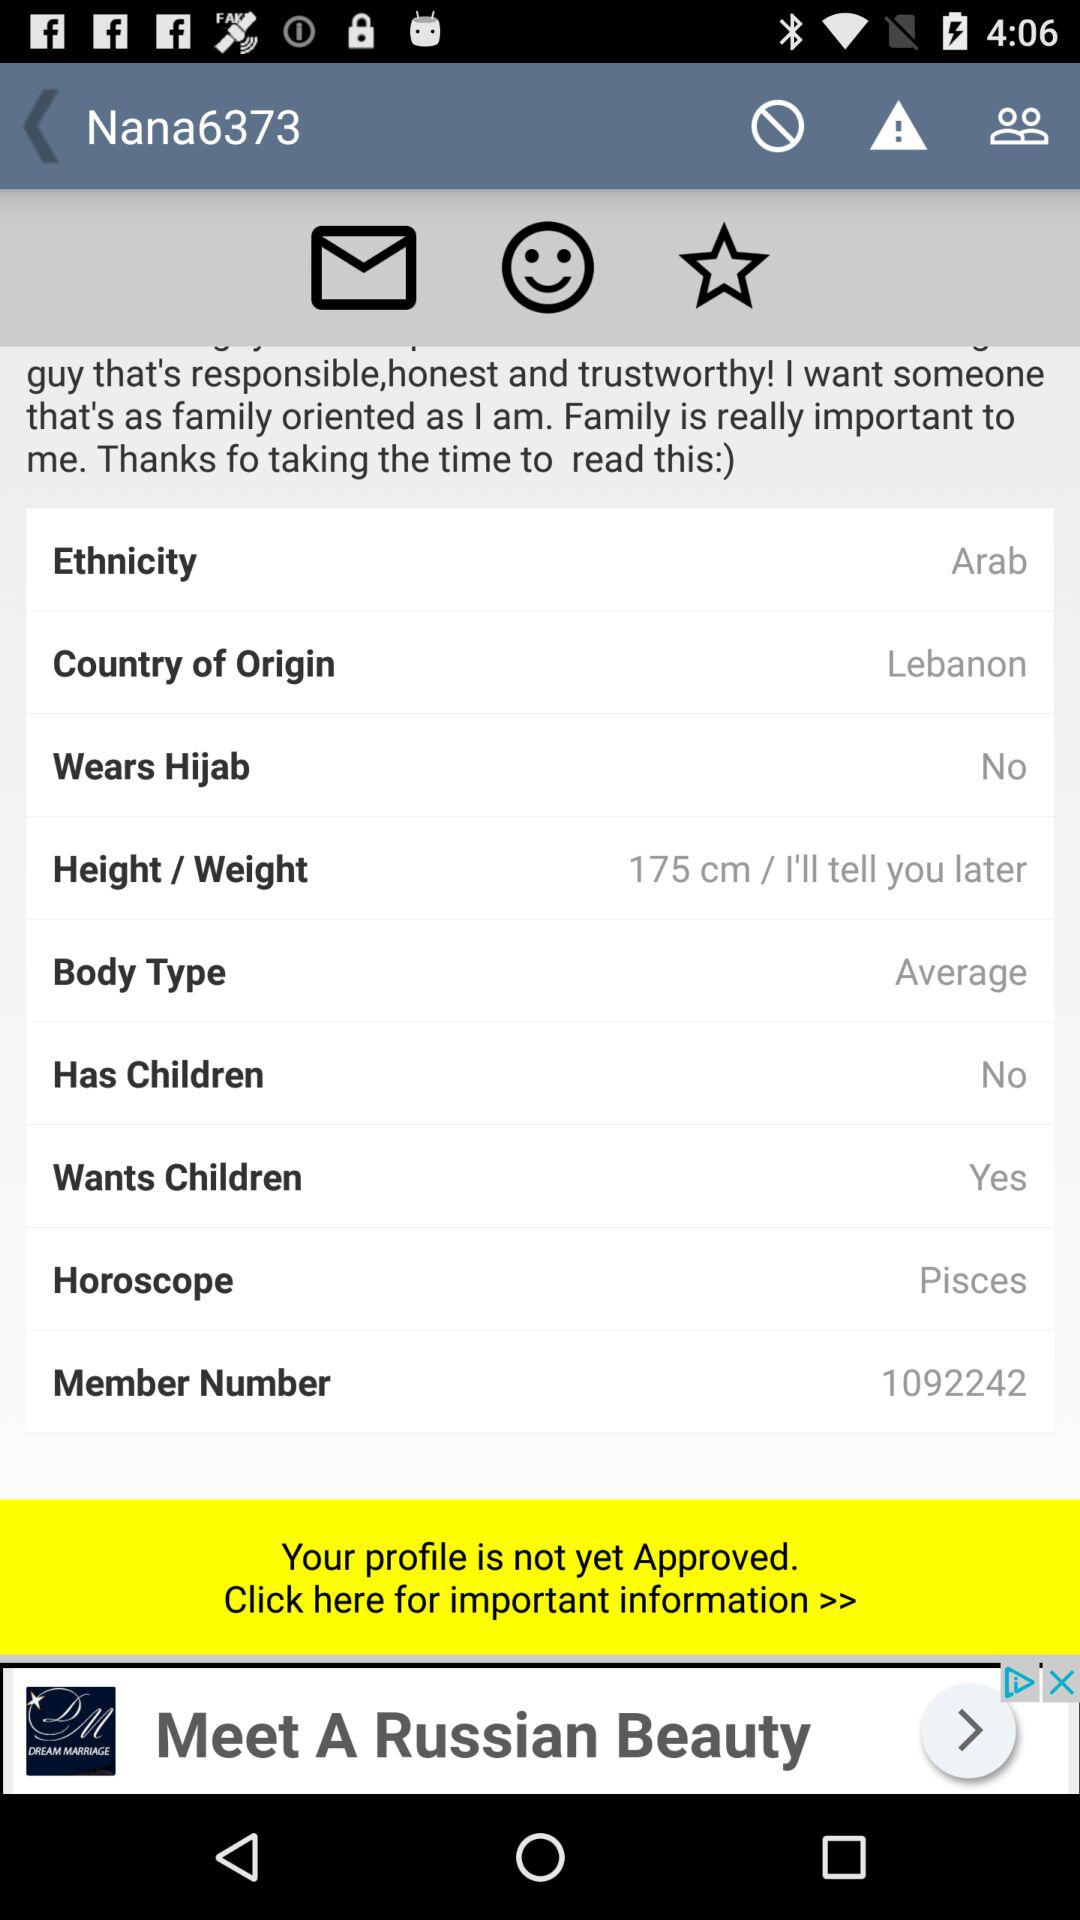What is the height of the person? The height of the person is 175 cm. 